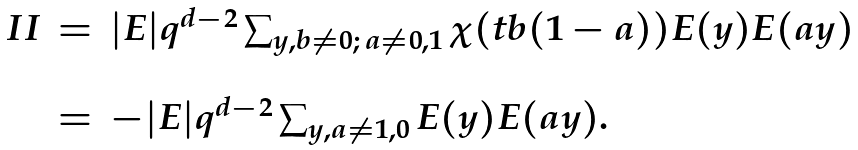Convert formula to latex. <formula><loc_0><loc_0><loc_500><loc_500>\begin{array} { l l l l } I I & = & | E | q ^ { d - 2 } \sum _ { y , b \neq 0 ; \, a \neq 0 , 1 } \chi ( t b ( 1 - a ) ) E ( y ) E ( a y ) \\ \\ & = & - | E | q ^ { d - 2 } \sum _ { y , a \not = 1 , 0 } E ( y ) E ( a y ) . \end{array}</formula> 